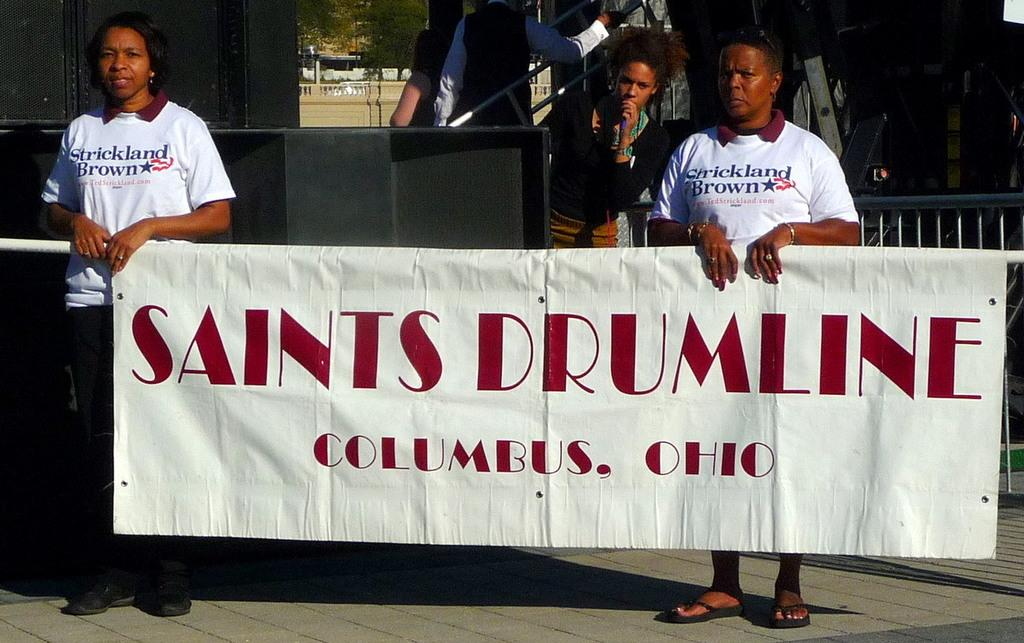<image>
Give a short and clear explanation of the subsequent image. Two people hold a banner for Saints Drumline from Columbus, Ohio. 